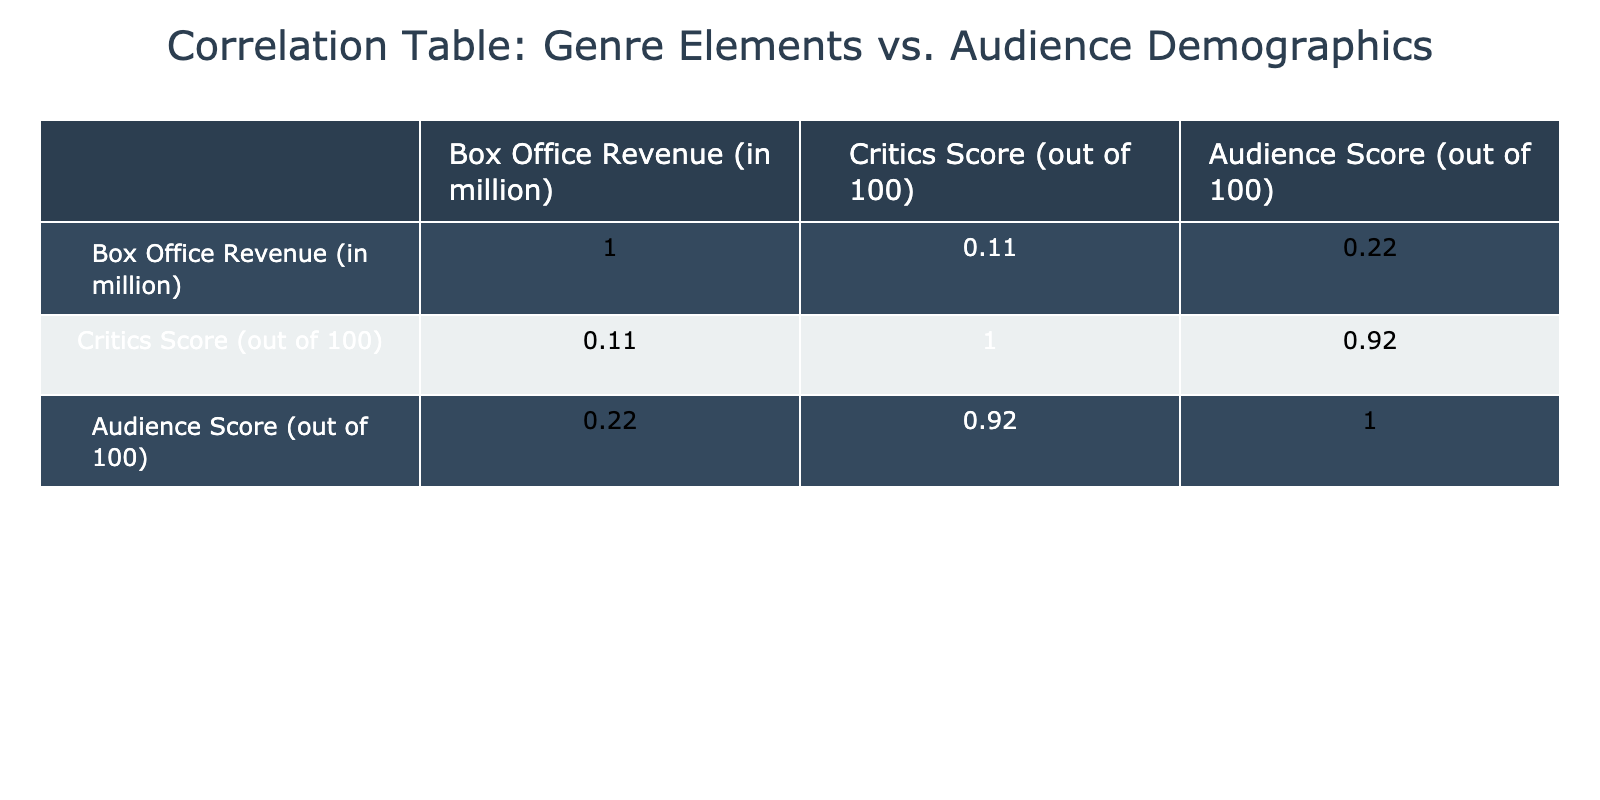What is the highest Box Office Revenue among the genres? By examining the Box Office Revenue values, Action for the 25-34 age group Male has the highest value at 90 million.
Answer: 90 million What is the correlation between Box Office Revenue and Audience Score? Looking at the correlation table, the correlation coefficient between Box Office Revenue and Audience Score is 0.61, indicating a positive correlation.
Answer: 0.61 Which genre has the lowest Critics Score? The Drama genre for the 25-34 Male group has the lowest Critics Score of 78.
Answer: 78 Are there any genres where Female audiences scored lower than Male audiences? Yes, in the Comedy genre for the 25-34 age group, the Female audience scored 85 while the Male audience scored 65.
Answer: Yes What is the average Audience Score for the Thriller genre? The Audience Scores for the Thriller genre are 77 (Male, 18-24), 82 (Female, 18-24), 84 (Male, 25-34), and 90 (Female, 25-34). The average is (77 + 82 + 84 + 90) / 4 = 333 / 4 = 83.25.
Answer: 83.25 Which age group of Male audiences scored the highest in the Drama genre? The 25-34 age group Male audiences scored 75, which is lower than the Female score of 95 in the same age group. The highest score for Male audiences in Drama is 75.
Answer: 75 Is there a relationship where Female audiences tend to give higher Audience Scores compared to Male audiences? Yes, when comparing scores across different genres, Female audiences consistently have higher Audience Scores than their Male counterparts, especially noticeable in Drama and Romantic genres.
Answer: Yes What is the difference in Box Office Revenue between the highest and lowest scoring genres in the Audience Score for the 18-24 age group? The highest Audience Score for 18-24 is found in Action with 88, and the lowest in Romantic with a score of 65. The Box Office Revenues for both are 80 million (Action) and 15 million (Romantic). The difference in revenues is 80 - 15 = 65 million.
Answer: 65 million 